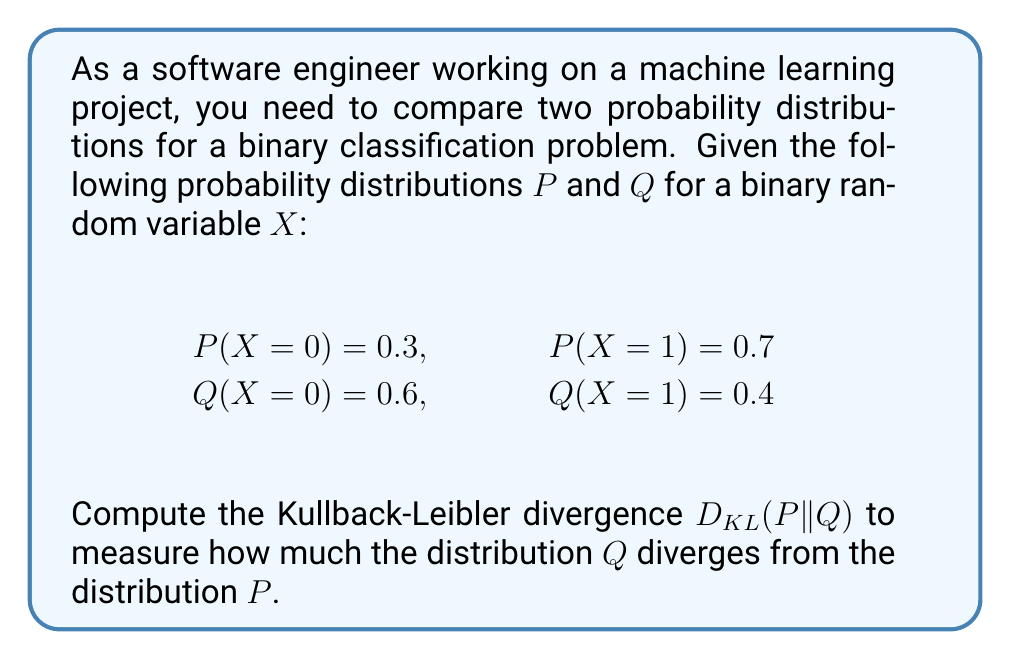Solve this math problem. Let's approach this step-by-step:

1) The Kullback-Leibler divergence for discrete probability distributions is defined as:

   $$D_{KL}(P||Q) = \sum_{x} P(x) \log\left(\frac{P(x)}{Q(x)}\right)$$

2) For our binary distribution, we need to calculate:

   $$D_{KL}(P||Q) = P(X=0) \log\left(\frac{P(X=0)}{Q(X=0)}\right) + P(X=1) \log\left(\frac{P(X=1)}{Q(X=1)}\right)$$

3) Let's substitute the given probabilities:

   $$D_{KL}(P||Q) = 0.3 \log\left(\frac{0.3}{0.6}\right) + 0.7 \log\left(\frac{0.7}{0.4}\right)$$

4) Simplify inside the logarithms:

   $$D_{KL}(P||Q) = 0.3 \log(0.5) + 0.7 \log(1.75)$$

5) Calculate the logarithms (using natural log):

   $$D_{KL}(P||Q) = 0.3 \cdot (-0.6931) + 0.7 \cdot 0.5596$$

6) Multiply:

   $$D_{KL}(P||Q) = -0.2079 + 0.3917$$

7) Sum the results:

   $$D_{KL}(P||Q) = 0.1838$$

Thus, the Kullback-Leibler divergence D_KL(P||Q) is approximately 0.1838 bits.
Answer: 0.1838 bits 